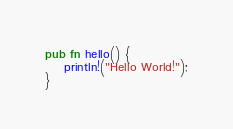Convert code to text. <code><loc_0><loc_0><loc_500><loc_500><_Rust_>pub fn hello() {
    println!("Hello World!");
}
</code> 